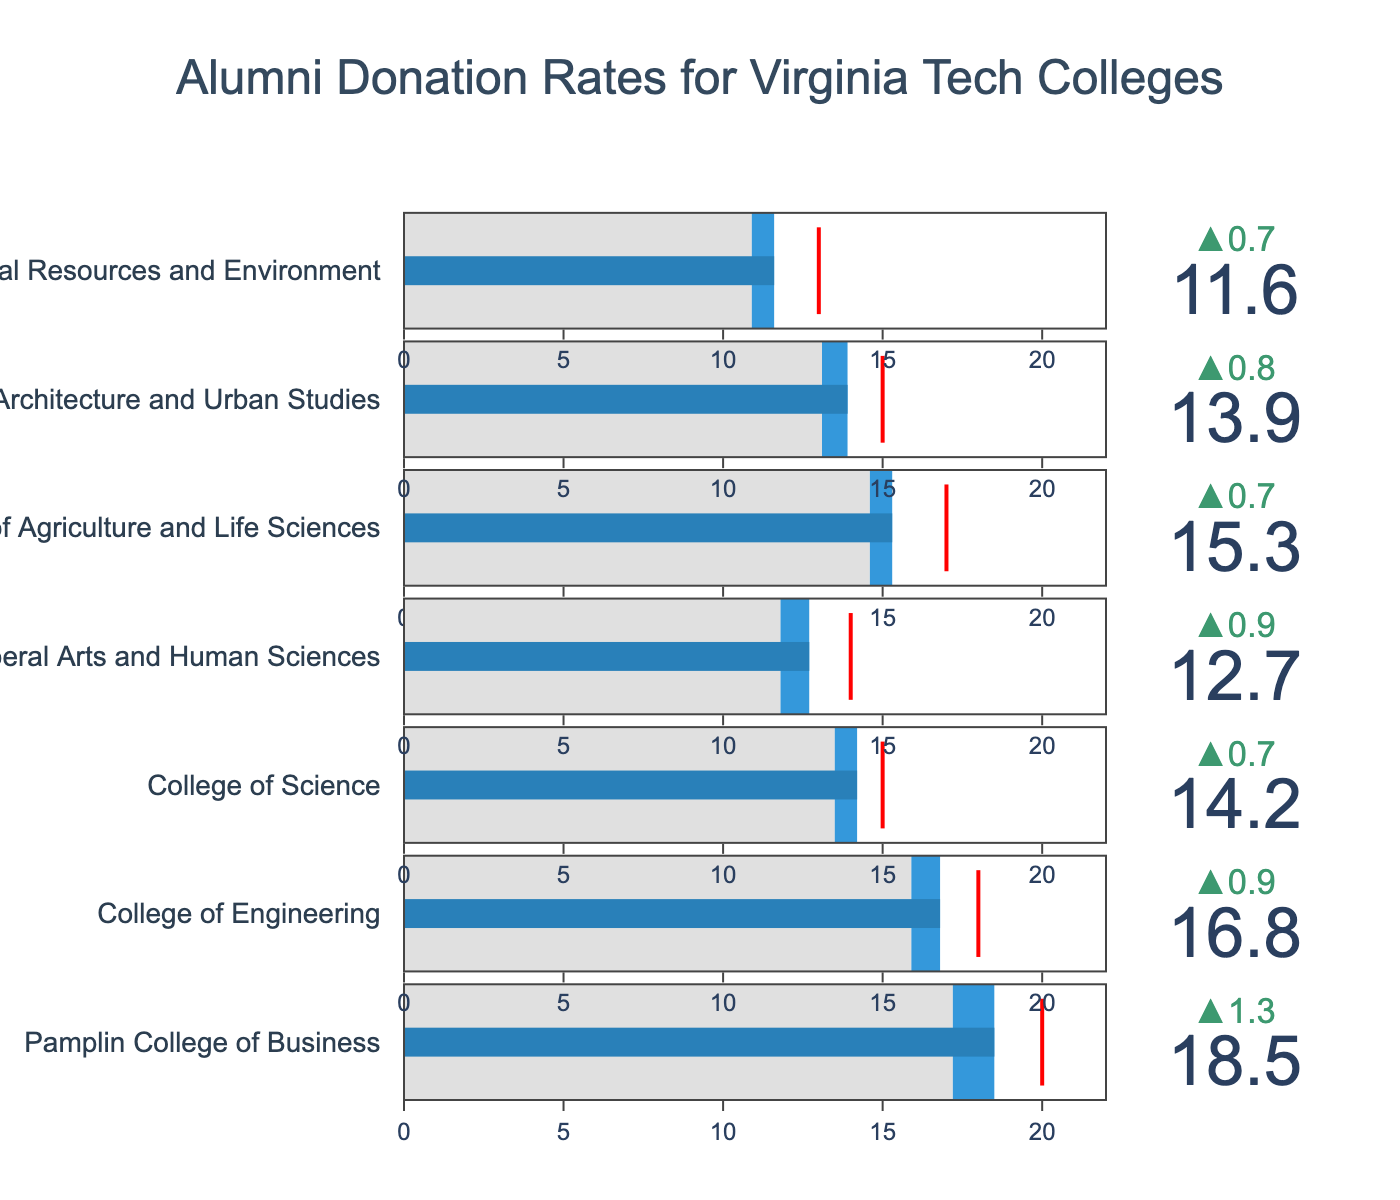What is the title of the figure? The title of the figure is at the top and is centered.
Answer: Alumni Donation Rates for Virginia Tech Colleges Which college has the highest actual donation rate? By looking at the bullet charts, the tallest bar represents the Pamplin College of Business with an actual donation rate of 18.5%.
Answer: Pamplin College of Business What is the actual donation rate for the College of Science? Find the bullet chart labeled "College of Science," which shows the actual donation rate.
Answer: 14.2% What is the difference between the target rate and the actual donation rate for the College of Engineering? The target rate for the College of Engineering is 18%, and the actual donation rate is 16.8%. Subtract the actual rate from the target rate: 18% - 16.8% = 1.2%.
Answer: 1.2% Which college had the greatest improvement in donation rate compared to the previous year? Look at the delta (Δ) values shown above each bullet chart, which represent the increase or decrease from the previous year’s rate. The College of Liberal Arts and Human Sciences had the highest delta with a 0.9% increase (12.7% - 11.8% = 0.9%).
Answer: College of Liberal Arts and Human Sciences Which colleges did not meet their target donation rates? Compare the actual donation rate to the target rate for each college. Pamplin College of Business, College of Engineering, College of Science, College of Liberal Arts and Human Sciences, College of Agriculture and Life Sciences, College of Architecture and Urban Studies, and College of Natural Resources and Environment all have actual donation rates lower than their target rates.
Answer: All colleges listed How does Pamplin College of Business's previous year rate compare to the College of Engineering's actual donation rate? Pamplin College of Business had a previous year rate of 17.2%, and the College of Engineering has an actual donation rate of 16.8%. Compare these values: 17.2% is greater than 16.8%.
Answer: 17.2% > 16.8% What is the average actual donation rate across all colleges? Sum all the actual donation rates and divide by the number of colleges: (18.5 + 16.8 + 14.2 + 12.7 + 15.3 + 13.9 + 11.6)/7 = 14.29%.
Answer: 14.29% Which college has the smallest difference between its actual donation rate and its previous year rate? Subtract the previous year rate from the actual donation rate for each college. The smallest difference is found for the College of Natural Resources and Environment: 11.6% - 10.9% = 0.7%.
Answer: College of Natural Resources and Environment 